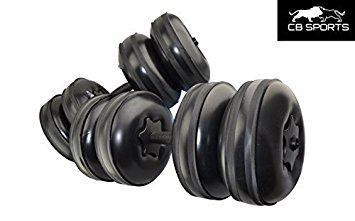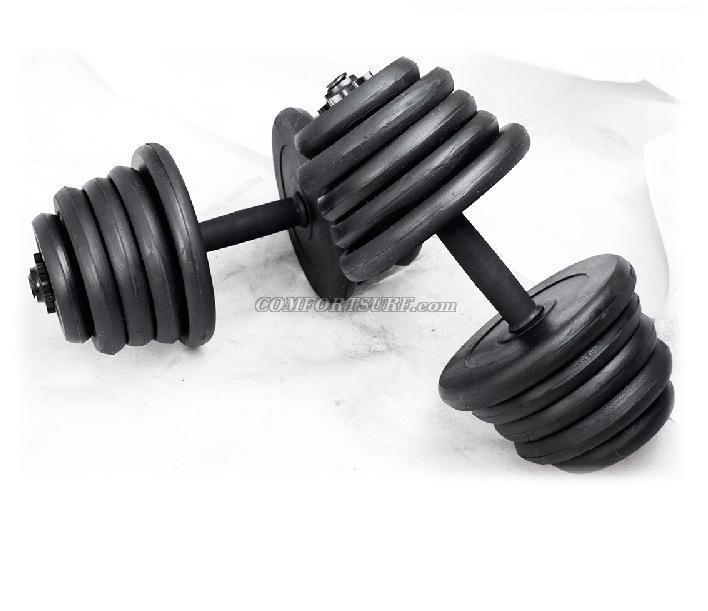The first image is the image on the left, the second image is the image on the right. For the images shown, is this caption "The left and right image contains a total of four dumbbells and four racks." true? Answer yes or no. No. The first image is the image on the left, the second image is the image on the right. Assess this claim about the two images: "There are four barbell stands.". Correct or not? Answer yes or no. No. 